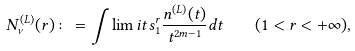Convert formula to latex. <formula><loc_0><loc_0><loc_500><loc_500>N ^ { ( L ) } _ { \nu } ( r ) \colon = \int \lim i t s _ { 1 } ^ { r } \frac { n ^ { ( L ) } ( t ) } { t ^ { 2 m - 1 } } d t \quad ( 1 < r < + \infty ) ,</formula> 